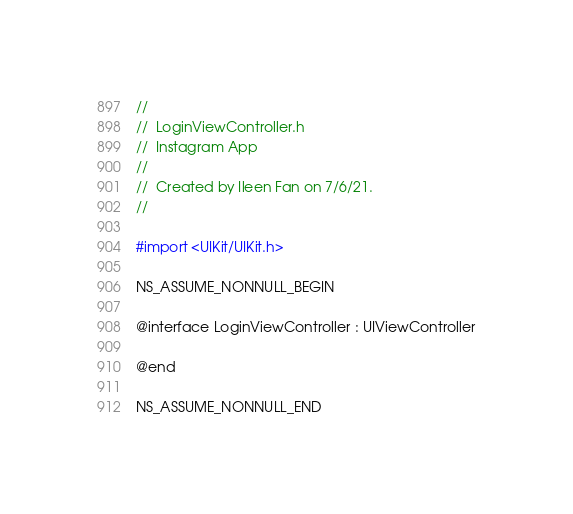Convert code to text. <code><loc_0><loc_0><loc_500><loc_500><_C_>//
//  LoginViewController.h
//  Instagram App
//
//  Created by Ileen Fan on 7/6/21.
//

#import <UIKit/UIKit.h>

NS_ASSUME_NONNULL_BEGIN

@interface LoginViewController : UIViewController

@end

NS_ASSUME_NONNULL_END
</code> 